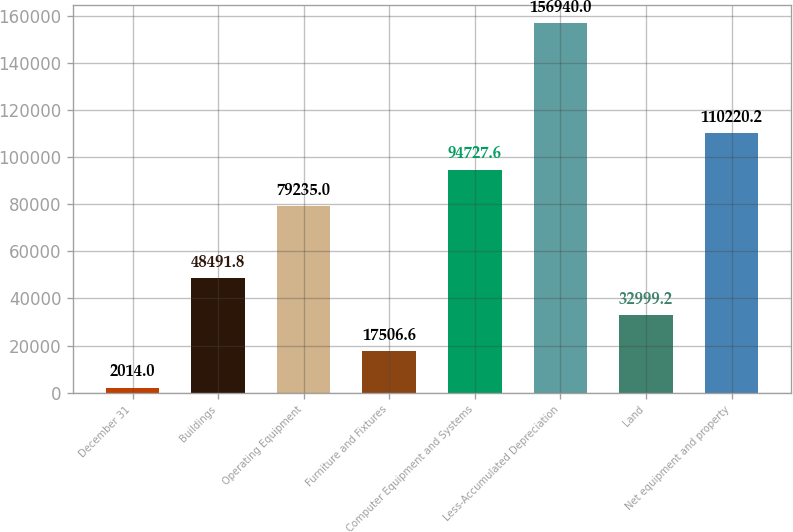Convert chart to OTSL. <chart><loc_0><loc_0><loc_500><loc_500><bar_chart><fcel>December 31<fcel>Buildings<fcel>Operating Equipment<fcel>Furniture and Fixtures<fcel>Computer Equipment and Systems<fcel>Less-Accumulated Depreciation<fcel>Land<fcel>Net equipment and property<nl><fcel>2014<fcel>48491.8<fcel>79235<fcel>17506.6<fcel>94727.6<fcel>156940<fcel>32999.2<fcel>110220<nl></chart> 